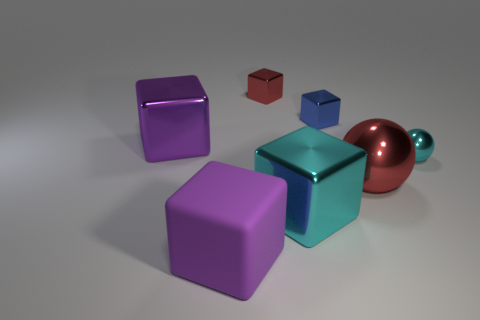Subtract 1 blocks. How many blocks are left? 4 Subtract all rubber cubes. How many cubes are left? 4 Subtract all blue cubes. How many cubes are left? 4 Subtract all yellow blocks. Subtract all cyan spheres. How many blocks are left? 5 Add 2 red metallic blocks. How many objects exist? 9 Subtract all blocks. How many objects are left? 2 Subtract 0 purple cylinders. How many objects are left? 7 Subtract all red balls. Subtract all tiny cyan matte blocks. How many objects are left? 6 Add 1 large purple shiny blocks. How many large purple shiny blocks are left? 2 Add 4 large cyan shiny balls. How many large cyan shiny balls exist? 4 